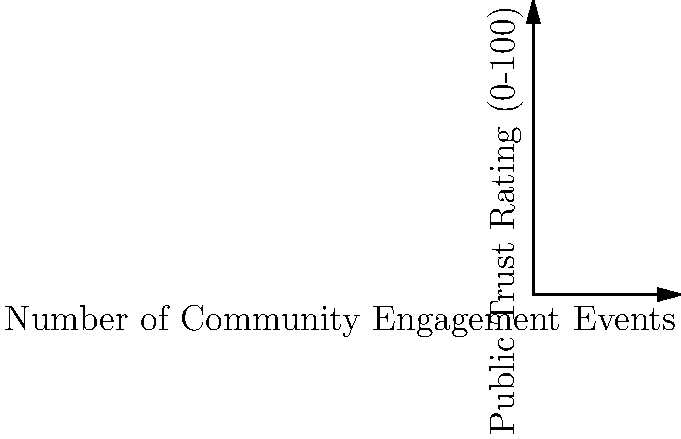Based on the bubble chart showing the relationship between community engagement events and public trust in law enforcement for four cities, which city demonstrates the strongest positive correlation between these two variables? To determine which city demonstrates the strongest positive correlation between community engagement events and public trust in law enforcement, we need to analyze the position and size of each bubble in the chart:

1. Identify the cities:
   - City A: (10 events, 30 trust rating)
   - City B: (20 events, 45 trust rating)
   - City C: (30 events, 60 trust rating)
   - City D: (40 events, 75 trust rating)

2. Observe the trend:
   As we move from City A to City D, both the number of community engagement events and the public trust rating increase, indicating a positive correlation.

3. Analyze the relationship:
   - City A has the lowest number of events and the lowest trust rating.
   - City D has the highest number of events and the highest trust rating.
   - Cities B and C fall in between, showing a consistent upward trend.

4. Consider bubble sizes:
   The bubble sizes increase from City A to City D, suggesting that the relationship becomes stronger as both variables increase.

5. Evaluate the correlation strength:
   City D shows the strongest positive correlation because it has:
   a) The highest number of community engagement events (40)
   b) The highest public trust rating (75)
   c) The largest bubble size, indicating the strongest relationship

Therefore, City D demonstrates the strongest positive correlation between community engagement events and public trust in law enforcement.
Answer: City D 